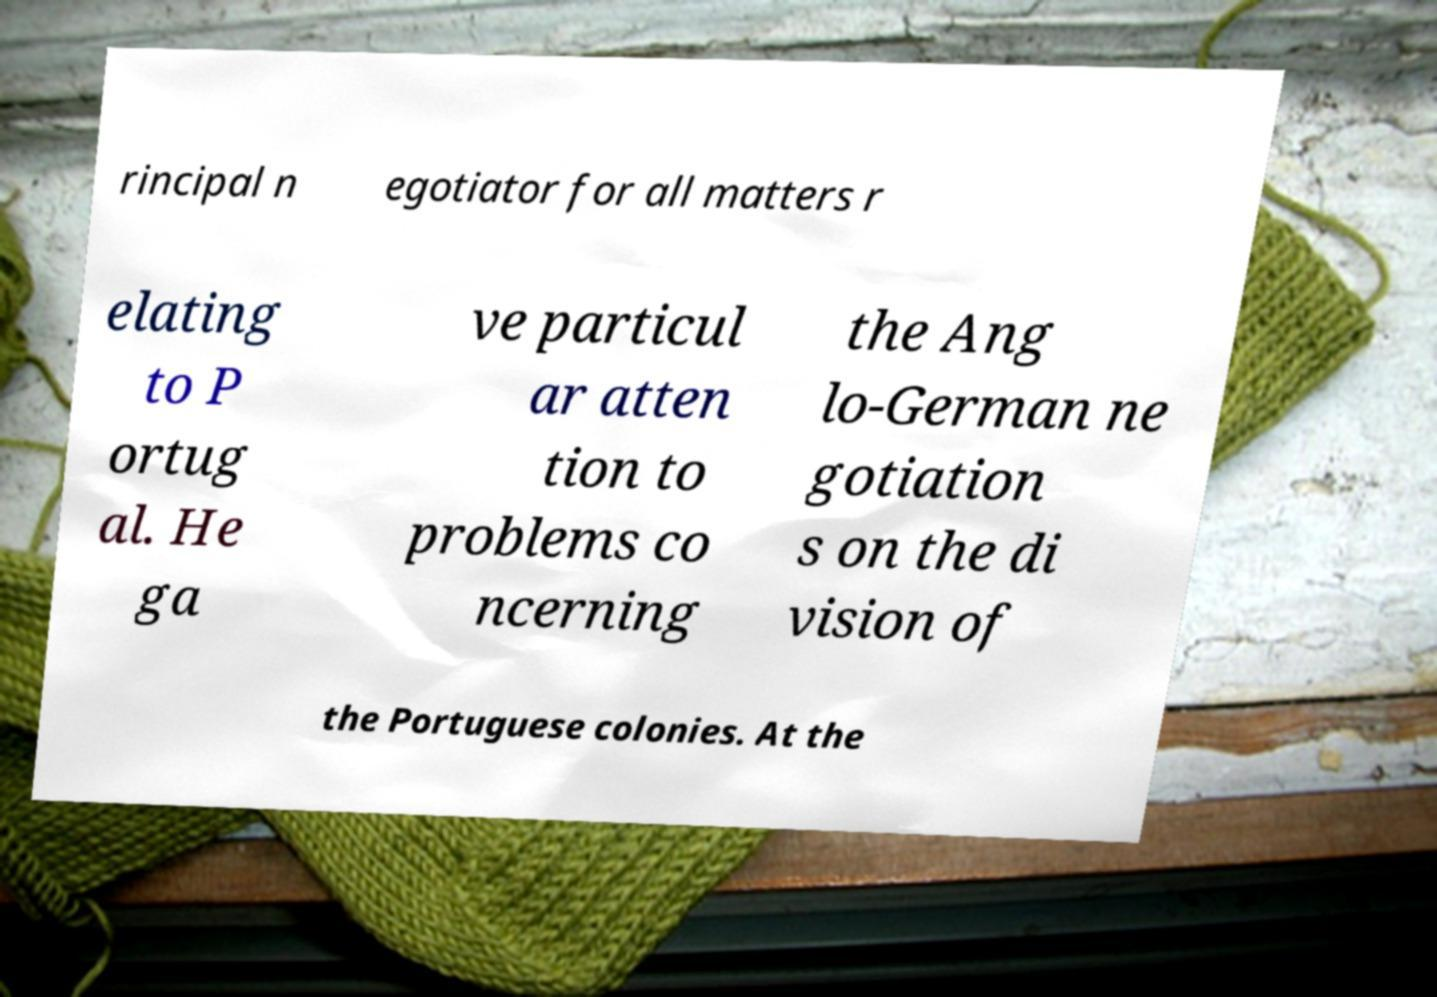Can you read and provide the text displayed in the image?This photo seems to have some interesting text. Can you extract and type it out for me? rincipal n egotiator for all matters r elating to P ortug al. He ga ve particul ar atten tion to problems co ncerning the Ang lo-German ne gotiation s on the di vision of the Portuguese colonies. At the 